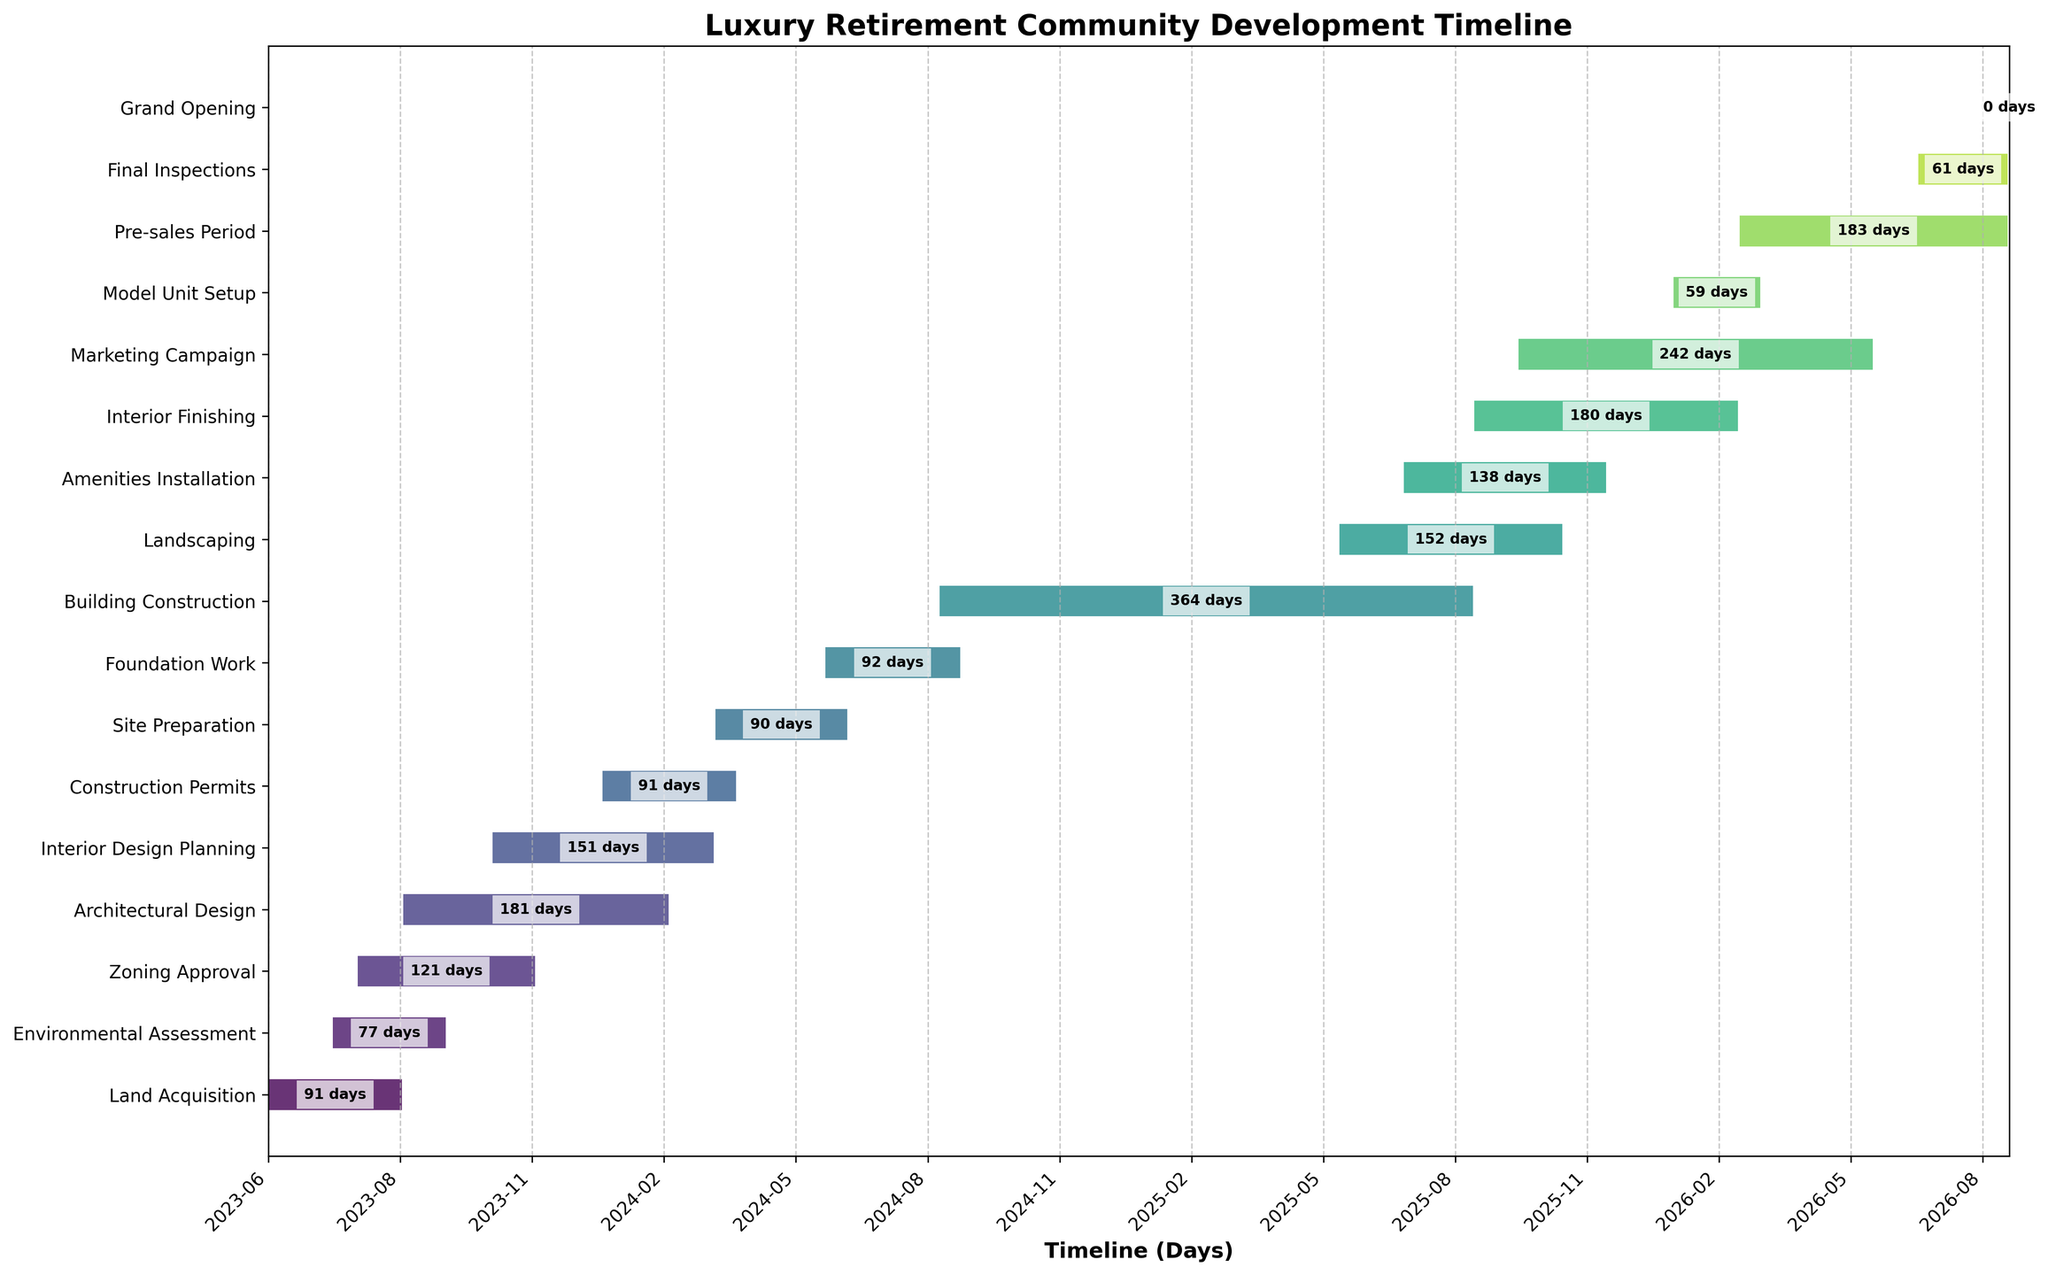What is the title of the Gantt Chart? The title of the Gantt Chart is typically displayed at the top of the figure. It helps the viewer understand what the chart is about. In this case, the title is "Luxury Retirement Community Development Timeline".
Answer: Luxury Retirement Community Development Timeline How many tasks are there in the project timeline? Count the number of tasks listed along the y-axis of the Gantt Chart. Each horizontal bar represents one task. The total number of tasks is 17.
Answer: 17 Which task has the shortest duration? To find the task with the shortest duration, look for the smallest horizontal bar. The duration is also indicated in days within the bar. The "Grand Opening" has the shortest duration of 1 day.
Answer: Grand Opening What's the total duration from the start of the first task to the end of the last task? Identify the start date of the first task ("Land Acquisition") and the end date of the last task ("Grand Opening"). Calculate the difference between 2023-06-01 and 2026-09-01. This is a project duration of 3 years and 3 months.
Answer: 3 years and 3 months When does the "Building Construction" task start and end? Locate the "Building Construction" task on the y-axis. Its start and end dates are marked at the left and right edges of its horizontal bar. According to the chart, it starts on 2024-09-01 and ends on 2025-08-31.
Answer: 2024-09-01 to 2025-08-31 Which tasks overlap with the "Interior Design Planning"? Find the "Interior Design Planning" bar and look for other bars that align with it horizontally. The overlapping tasks are those whose bars touch or coincide with the timeframe of "Interior Design Planning" from 2023-11-01 to 2024-03-31. These are “Architectural Design” and “Construction Permits.”
Answer: Architectural Design, Construction Permits How many tasks have a duration longer than 6 months? A duration longer than 6 months is over approximately 182 days. Look for the bars whose duration text inside the bars exceeds 182 days. Tasks like "Architectural Design," "Building Construction," "Marketing Campaign," "Interior Design Planning," and "Pre-sales Period" qualify.
Answer: 5 Which two tasks finish on the same day? Look for tasks that have the same end date. Based on visual inspection, both "Environmental Assessment" and "Interior Finishing" end on 2026-02-28.
Answer: Environmental Assessment, Interior Finishing On average, how many days does each task span? Calculate the average duration by summing all task durations divided by the number of tasks. Total duration sum is 2395 days, divided by 17 tasks equals approximately 140.88 days.
Answer: 140.88 days 